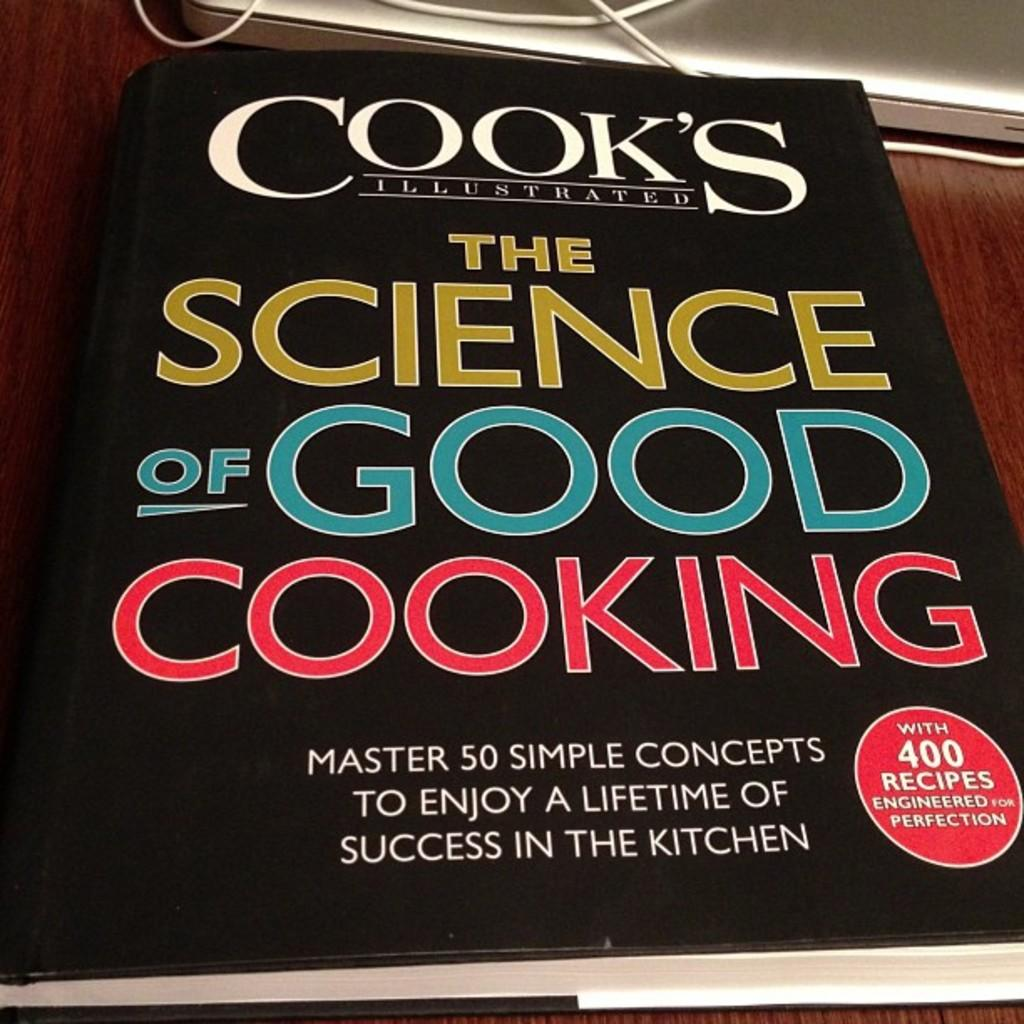<image>
Offer a succinct explanation of the picture presented. A book has 400 recipes in it and fifty concepts to master. 